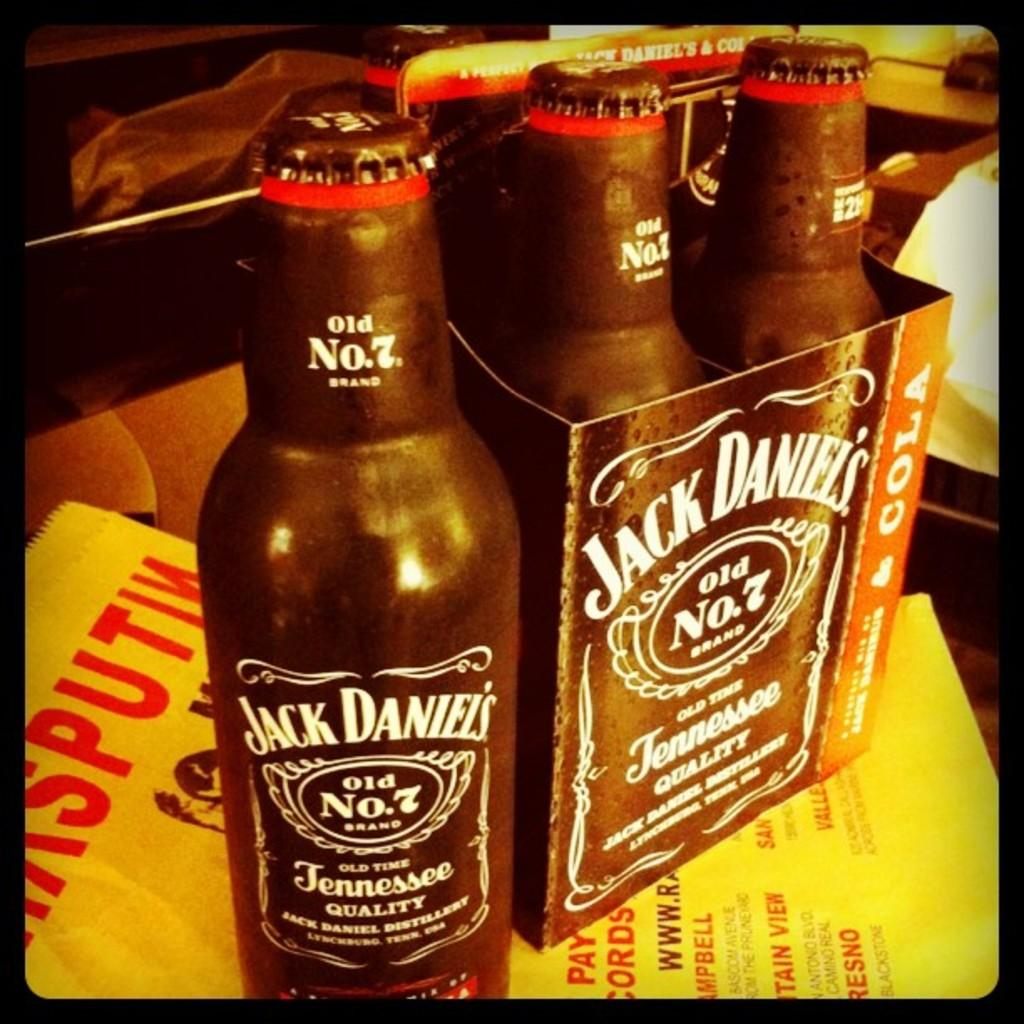<image>
Give a short and clear explanation of the subsequent image. One black Jack Daniels bottle out with the others still in the box. 